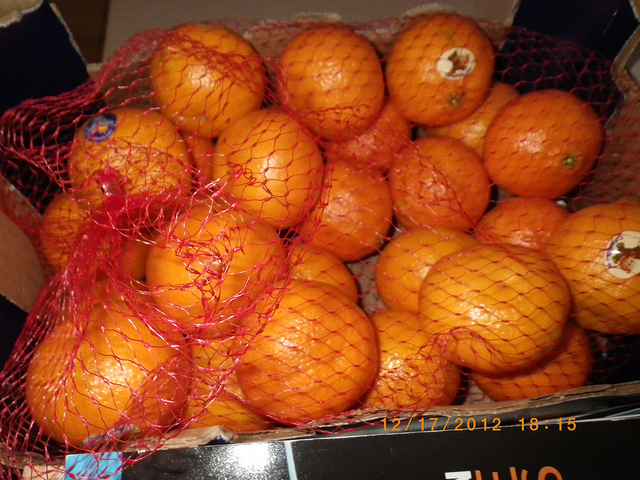<image>In what city was this fruit picked? It is unknown in what city the fruit was picked. In what city was this fruit picked? I am not sure in what city the fruit was picked. It can be either 'zuko', 'orange', 'orlando', 'tampa', 'oxnard', 'miami', or 'radcliff'. 